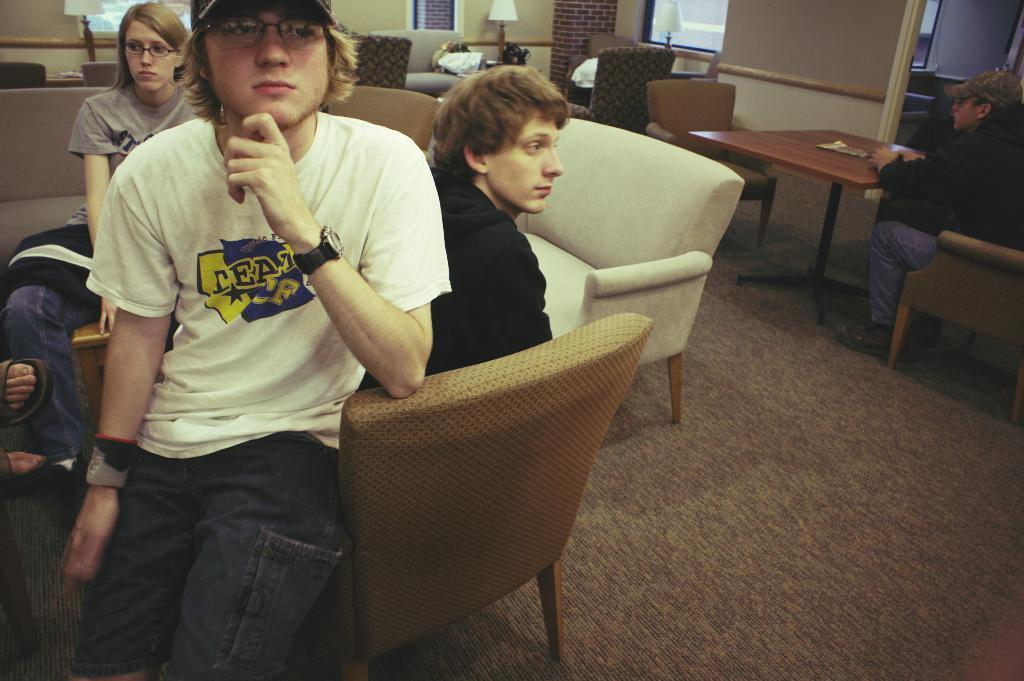How many people are sitting on chairs in the image? There are three people sitting on chairs on the left side of the image. What can be seen in the middle of the image? There are many chairs and a table in the middle of the image. Can you describe the man on the right side of the image? The man on the right side of the image is wearing trousers, shoes, and a cap. How many trains can be seen in the image? There are no trains present in the image. What color is the man's hand in the image? The provided facts do not mention the color of the man's hand, so it cannot be determined from the image. 